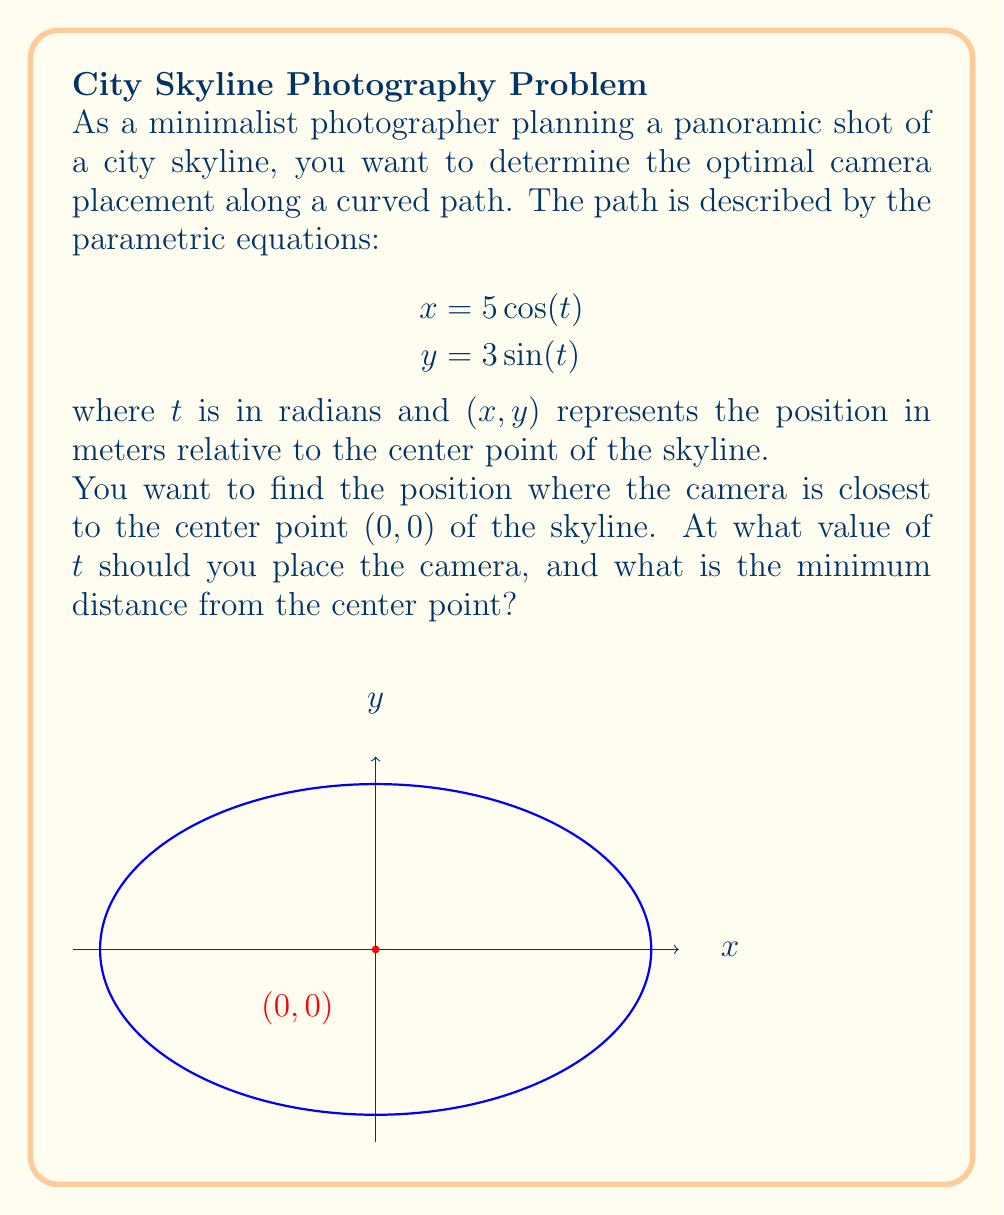Solve this math problem. Let's approach this step-by-step:

1) The distance $d$ from any point $(x,y)$ to the origin $(0,0)$ is given by:

   $$d = \sqrt{x^2 + y^2}$$

2) Substituting our parametric equations:

   $$d = \sqrt{(5\cos(t))^2 + (3\sin(t))^2}$$

3) Simplify:

   $$d = \sqrt{25\cos^2(t) + 9\sin^2(t)}$$

4) To find the minimum distance, we need to minimize this function. We can do this by finding where its derivative equals zero. However, it's easier to minimize $d^2$ instead (it will have the same minimum point):

   $$d^2 = 25\cos^2(t) + 9\sin^2(t)$$

5) Take the derivative with respect to $t$:

   $$\frac{d}{dt}(d^2) = -50\cos(t)\sin(t) + 18\sin(t)\cos(t) = -32\sin(t)\cos(t)$$

6) Set this equal to zero and solve:

   $$-32\sin(t)\cos(t) = 0$$

   This is true when $\sin(t) = 0$ or $\cos(t) = 0$

7) $\sin(t) = 0$ when $t = 0, \pi, 2\pi, ...$
   $\cos(t) = 0$ when $t = \frac{\pi}{2}, \frac{3\pi}{2}, ...$

8) To determine which of these gives the minimum distance, we can plug them back into our original distance formula:

   At $t = 0$ or $\pi$: $d = 5$
   At $t = \frac{\pi}{2}$ or $\frac{3\pi}{2}$: $d = 3$

9) Therefore, the minimum distance occurs at $t = \frac{\pi}{2}$ or $\frac{3\pi}{2}$, and the minimum distance is 3 meters.
Answer: $t = \frac{\pi}{2}$ or $\frac{3\pi}{2}$, minimum distance = 3 meters 